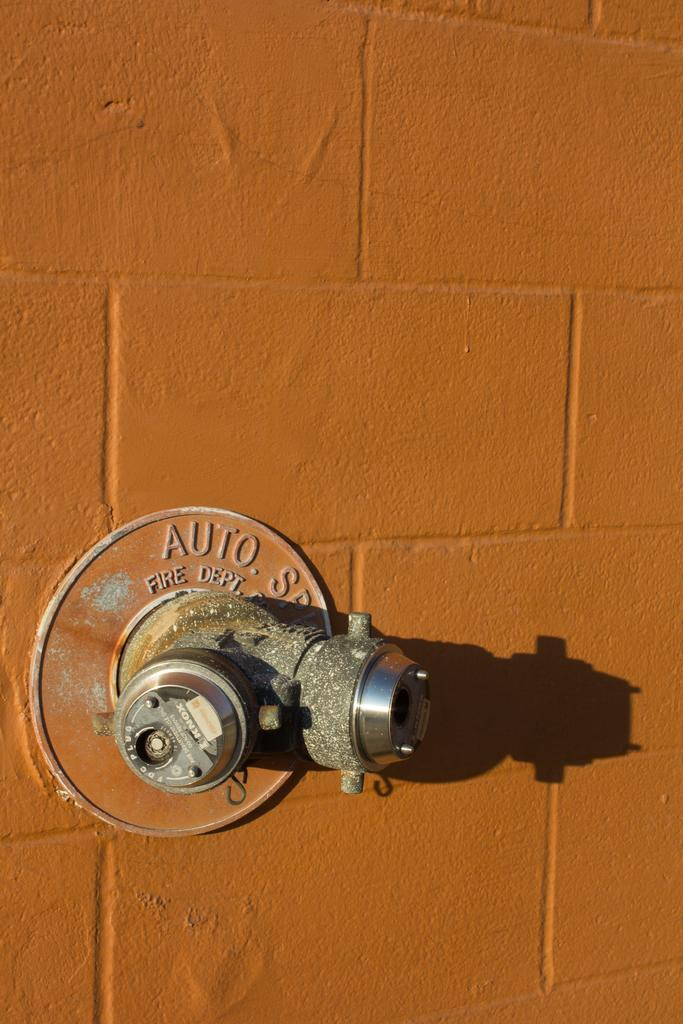What type of wall is visible in the image? There is a brick wall in the image. What color is the brick wall? The brick wall is painted orange. What can be seen on the left side of the image? There is a tap on the left side of the image. Is there a boy sitting on a chair in the image? There is no boy or chair present in the image. 